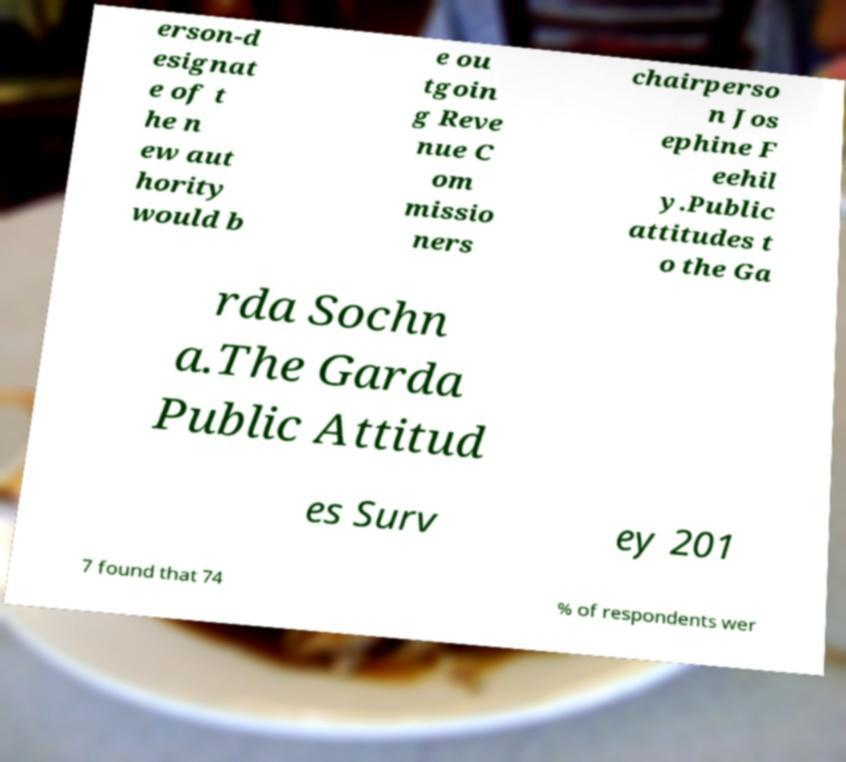Can you accurately transcribe the text from the provided image for me? erson-d esignat e of t he n ew aut hority would b e ou tgoin g Reve nue C om missio ners chairperso n Jos ephine F eehil y.Public attitudes t o the Ga rda Sochn a.The Garda Public Attitud es Surv ey 201 7 found that 74 % of respondents wer 